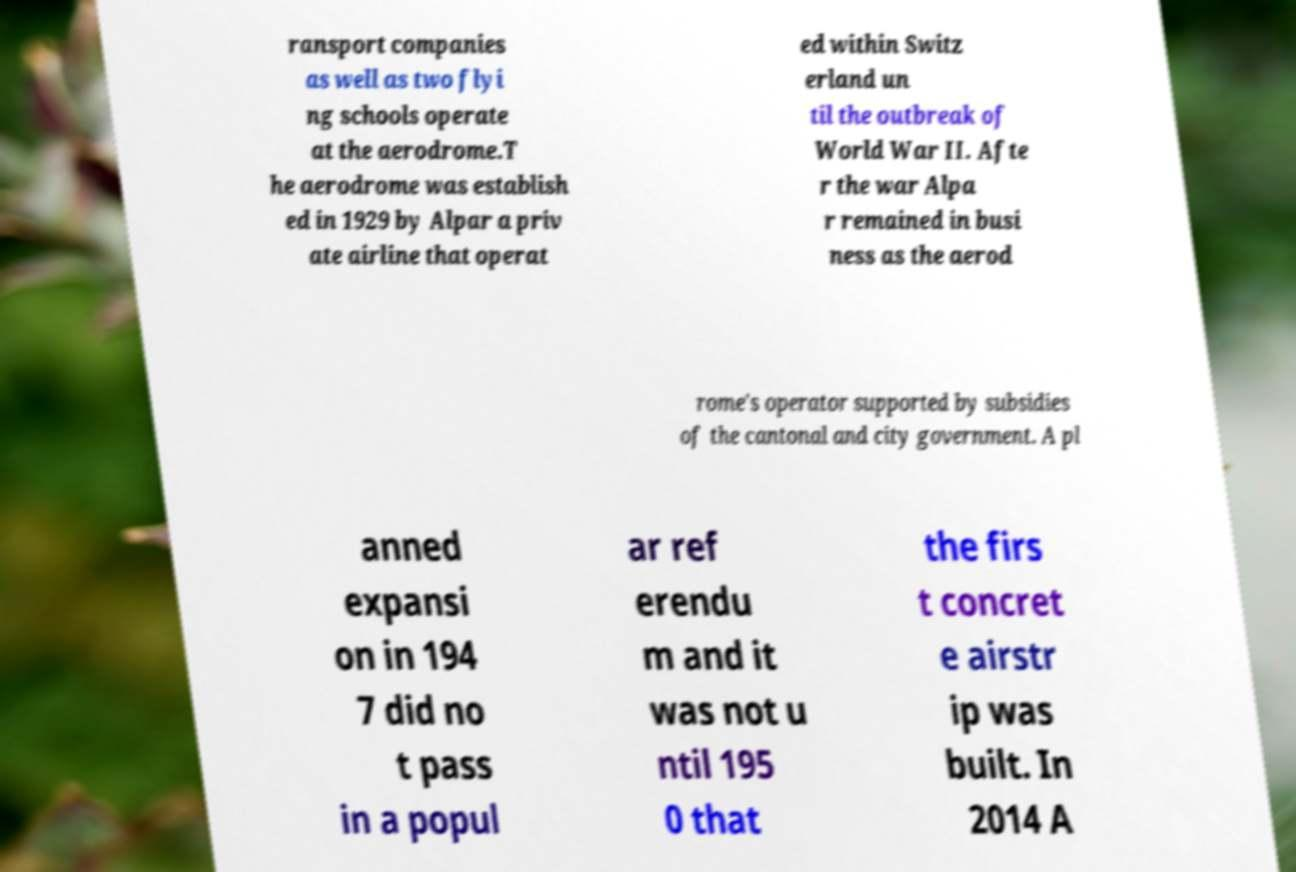Please read and relay the text visible in this image. What does it say? ransport companies as well as two flyi ng schools operate at the aerodrome.T he aerodrome was establish ed in 1929 by Alpar a priv ate airline that operat ed within Switz erland un til the outbreak of World War II. Afte r the war Alpa r remained in busi ness as the aerod rome's operator supported by subsidies of the cantonal and city government. A pl anned expansi on in 194 7 did no t pass in a popul ar ref erendu m and it was not u ntil 195 0 that the firs t concret e airstr ip was built. In 2014 A 